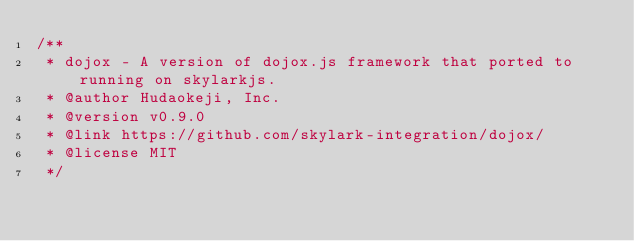Convert code to text. <code><loc_0><loc_0><loc_500><loc_500><_JavaScript_>/**
 * dojox - A version of dojox.js framework that ported to running on skylarkjs.
 * @author Hudaokeji, Inc.
 * @version v0.9.0
 * @link https://github.com/skylark-integration/dojox/
 * @license MIT
 */</code> 